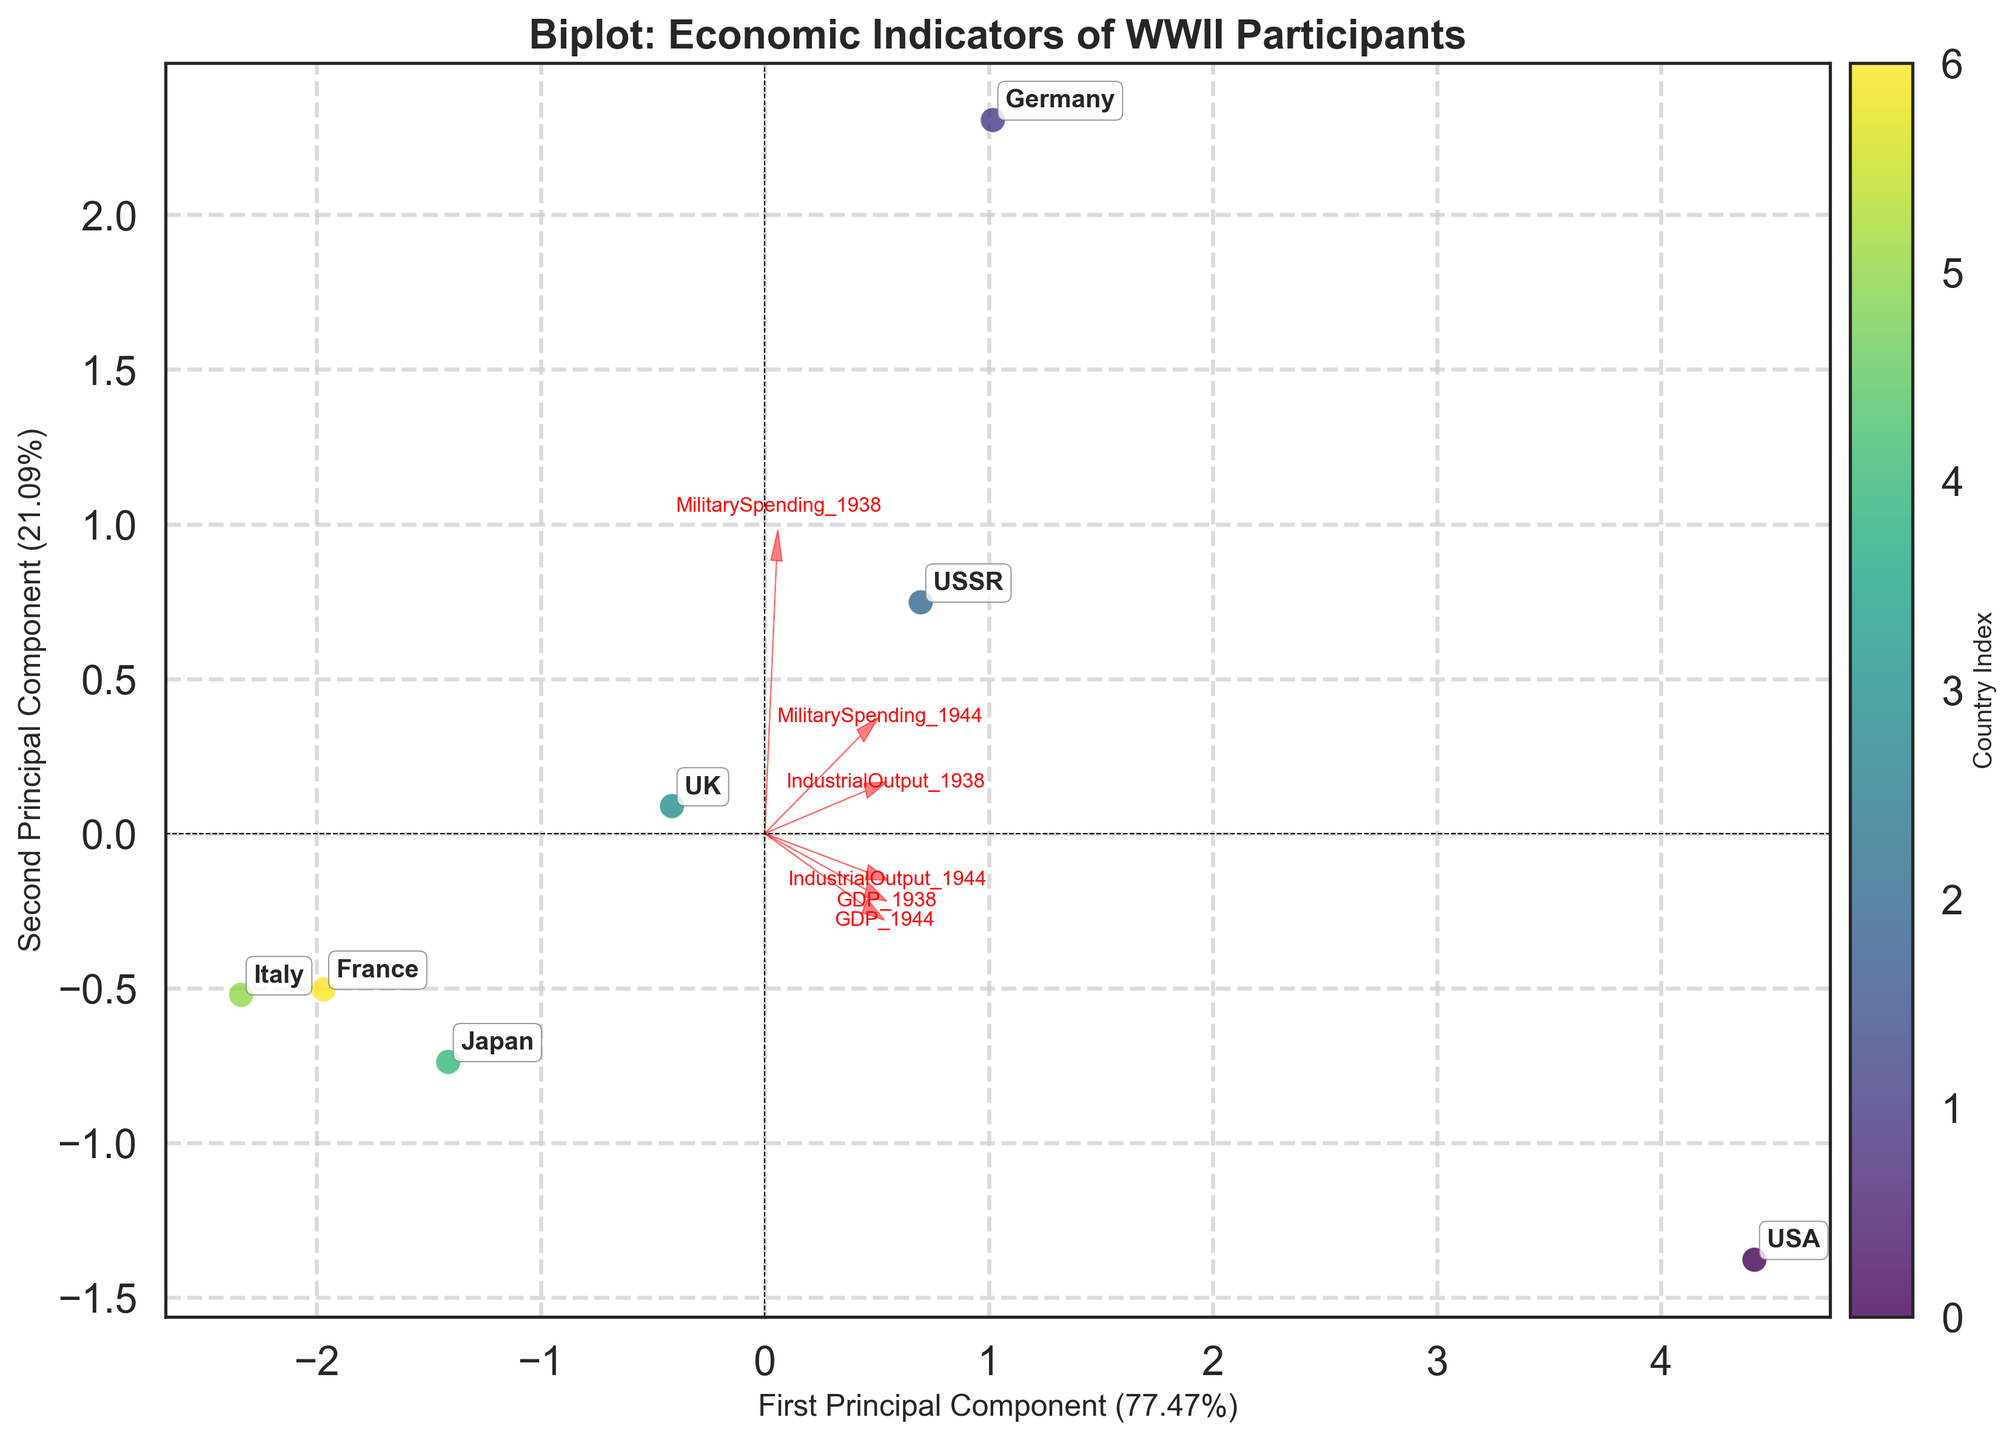What is the title of the figure? The title of the figure is displayed at the top and reads: "Biplot: Economic Indicators of WWII Participants."
Answer: Biplot: Economic Indicators of WWII Participants How many countries are represented in the biplot? Count the number of unique data points listed with country labels.
Answer: 7 Which country has the highest coordinate value on the first principal component? Look at the country with the rightmost point on the x-axis (First Principal Component).
Answer: USA Which two features are most closely aligned with the first principal component? Identify the features whose arrows are most aligned horizontally with the x-axis, indicating stronger correlations.
Answer: GDP_1938 and GDP_1944 How did Germany's economic indicators change from 1938 to 1944? Compare the change in coordinates of Germany for GDP, IndustrialOutput, and MilitarySpending both from 1938 to 1944 using the associated arrow directions.
Answer: Increased GDP, Industrial Output; Drastically increased Military Spending Which country shows a decline in GDP from 1938 to 1944? Look for countries with arrows pointing from a positive to a less positive or negative values, indicating a decrease in GDP.
Answer: France What percentage of the variance is explained by the first principal component? Read the percentage provided next to the x-axis label "First Principal Component."
Answer: Approximately 76% Which countries had higher Military Spending in 1944 than in 1938? Check for countries whose coordinate for MilitarySpending_1944 is higher than MilitarySpending_1938 by following direction and length of arrows.
Answer: USA, Germany, USSR, UK, Japan How do the UK's economic indicators compare to Italy's? Analyze positions of UK and Italy on the biplot along the directions of arrows for GDP, IndustrialOutput, and MilitarySpending for both 1938 and 1944.
Answer: UK had higher GDP, Industrial Output, and Military Spending especially in 1944 How do the GDPs of the USA and USSR compare between 1938 and 1944? Observe and compare the proximity to and the direction along the GDP arrows for both years for USA and USSR.
Answer: Both increased, USA increased more 